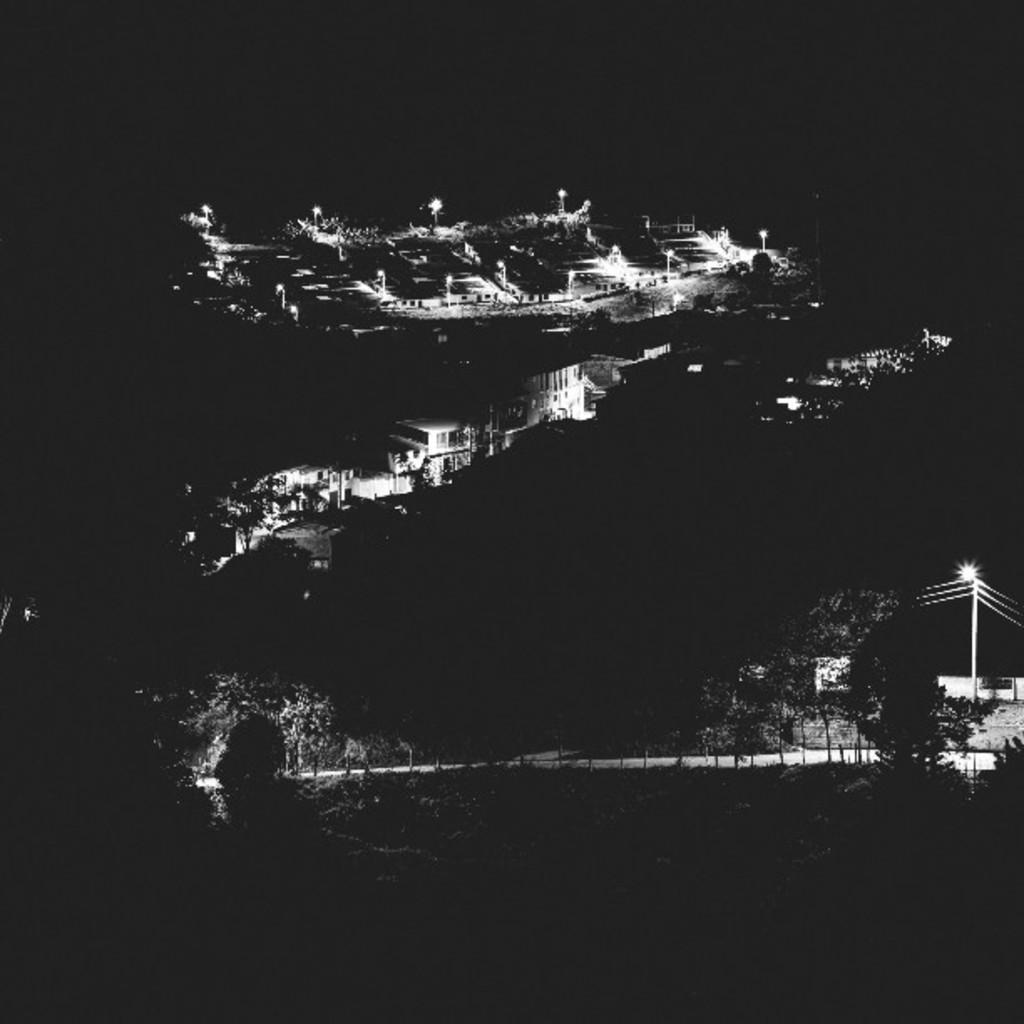How would you summarize this image in a sentence or two? This picture shows few buildings and we see trees and pole lights. 